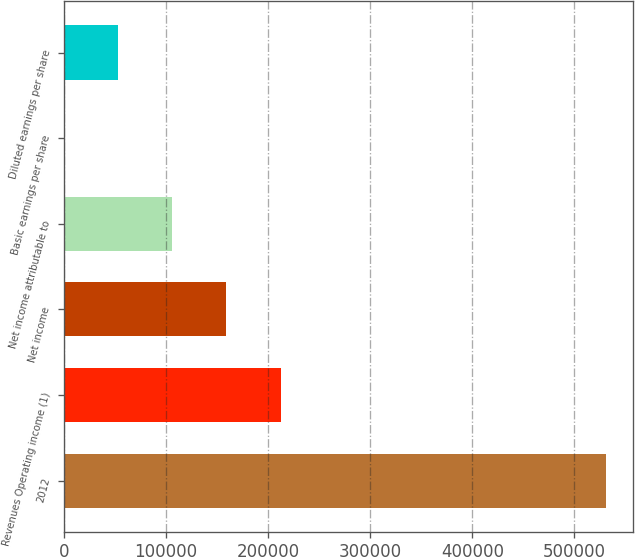<chart> <loc_0><loc_0><loc_500><loc_500><bar_chart><fcel>2012<fcel>Revenues Operating income (1)<fcel>Net income<fcel>Net income attributable to<fcel>Basic earnings per share<fcel>Diluted earnings per share<nl><fcel>530505<fcel>212202<fcel>159152<fcel>106102<fcel>0.78<fcel>53051.2<nl></chart> 